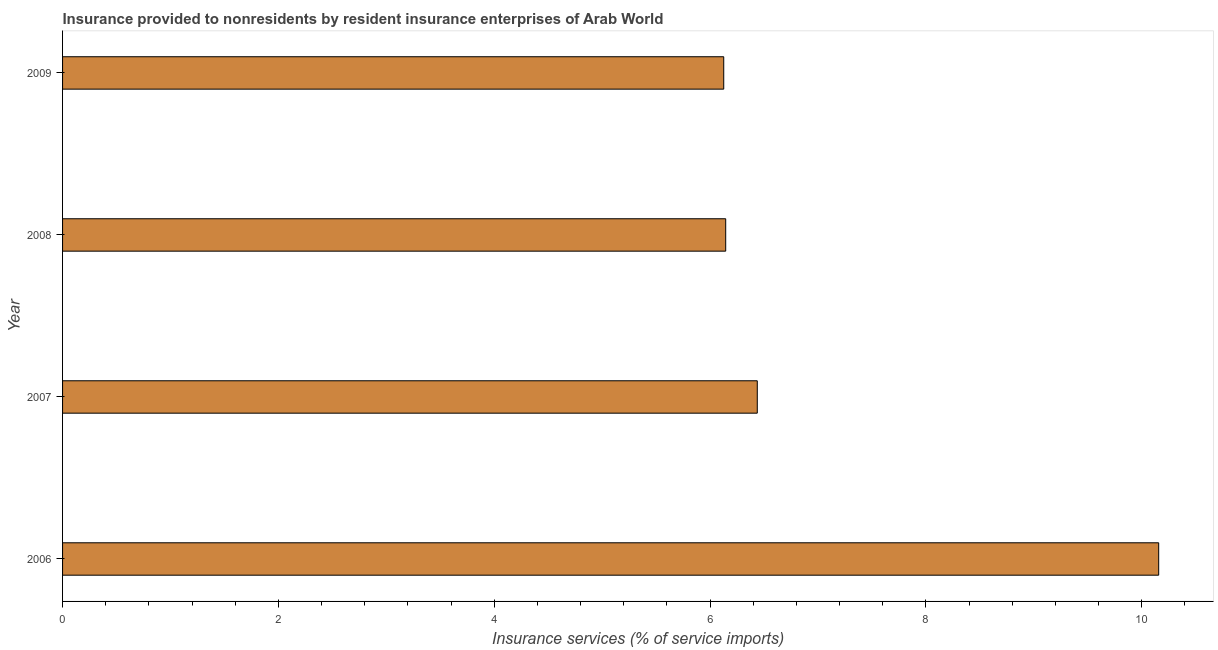Does the graph contain grids?
Your answer should be compact. No. What is the title of the graph?
Your response must be concise. Insurance provided to nonresidents by resident insurance enterprises of Arab World. What is the label or title of the X-axis?
Offer a terse response. Insurance services (% of service imports). What is the insurance and financial services in 2006?
Give a very brief answer. 10.16. Across all years, what is the maximum insurance and financial services?
Provide a succinct answer. 10.16. Across all years, what is the minimum insurance and financial services?
Make the answer very short. 6.13. What is the sum of the insurance and financial services?
Make the answer very short. 28.87. What is the difference between the insurance and financial services in 2007 and 2009?
Your answer should be compact. 0.31. What is the average insurance and financial services per year?
Offer a terse response. 7.22. What is the median insurance and financial services?
Offer a very short reply. 6.29. Is the insurance and financial services in 2006 less than that in 2008?
Provide a succinct answer. No. What is the difference between the highest and the second highest insurance and financial services?
Provide a succinct answer. 3.72. What is the difference between the highest and the lowest insurance and financial services?
Keep it short and to the point. 4.03. How many years are there in the graph?
Keep it short and to the point. 4. What is the Insurance services (% of service imports) of 2006?
Your response must be concise. 10.16. What is the Insurance services (% of service imports) in 2007?
Give a very brief answer. 6.44. What is the Insurance services (% of service imports) of 2008?
Provide a succinct answer. 6.14. What is the Insurance services (% of service imports) in 2009?
Offer a very short reply. 6.13. What is the difference between the Insurance services (% of service imports) in 2006 and 2007?
Provide a succinct answer. 3.72. What is the difference between the Insurance services (% of service imports) in 2006 and 2008?
Ensure brevity in your answer.  4.01. What is the difference between the Insurance services (% of service imports) in 2006 and 2009?
Provide a short and direct response. 4.03. What is the difference between the Insurance services (% of service imports) in 2007 and 2008?
Your answer should be compact. 0.29. What is the difference between the Insurance services (% of service imports) in 2007 and 2009?
Your answer should be very brief. 0.31. What is the difference between the Insurance services (% of service imports) in 2008 and 2009?
Your answer should be compact. 0.02. What is the ratio of the Insurance services (% of service imports) in 2006 to that in 2007?
Your response must be concise. 1.58. What is the ratio of the Insurance services (% of service imports) in 2006 to that in 2008?
Your response must be concise. 1.65. What is the ratio of the Insurance services (% of service imports) in 2006 to that in 2009?
Offer a very short reply. 1.66. What is the ratio of the Insurance services (% of service imports) in 2007 to that in 2008?
Provide a succinct answer. 1.05. What is the ratio of the Insurance services (% of service imports) in 2007 to that in 2009?
Keep it short and to the point. 1.05. 